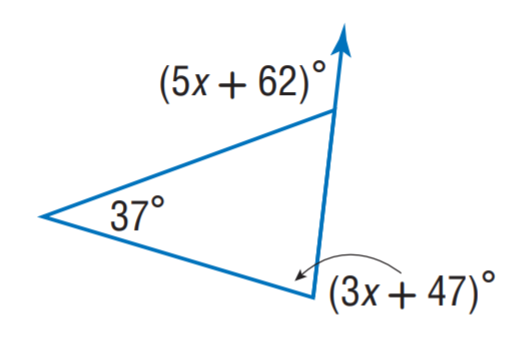Question: Find x.
Choices:
A. 9
B. 11
C. 37
D. 47
Answer with the letter. Answer: B 